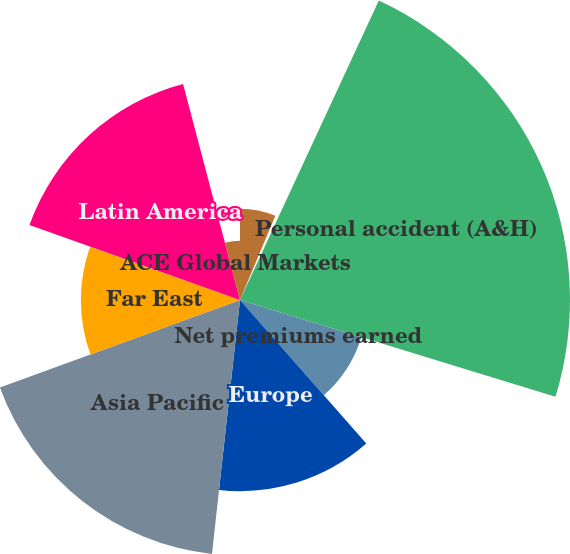<chart> <loc_0><loc_0><loc_500><loc_500><pie_chart><fcel>Property and all other<fcel>Casualty<fcel>Personal accident (A&H)<fcel>Net premiums earned<fcel>Europe<fcel>Asia Pacific<fcel>Far East<fcel>Latin America<fcel>ACE Global Markets<nl><fcel>6.32%<fcel>0.59%<fcel>22.83%<fcel>8.78%<fcel>13.23%<fcel>17.68%<fcel>11.01%<fcel>15.46%<fcel>4.1%<nl></chart> 